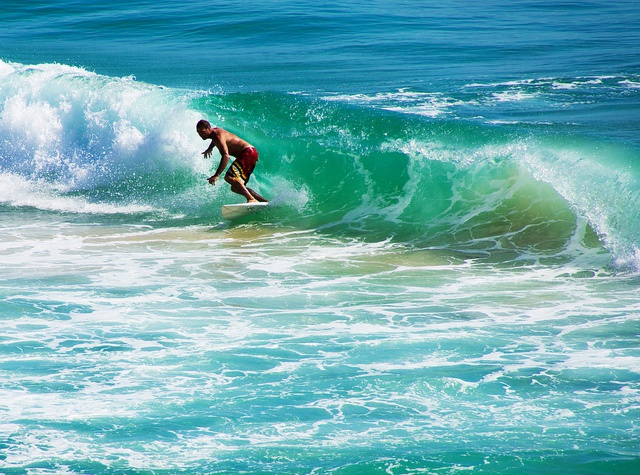Describe the objects in this image and their specific colors. I can see people in teal, black, maroon, and tan tones and surfboard in teal, gray, darkgreen, white, and darkgray tones in this image. 